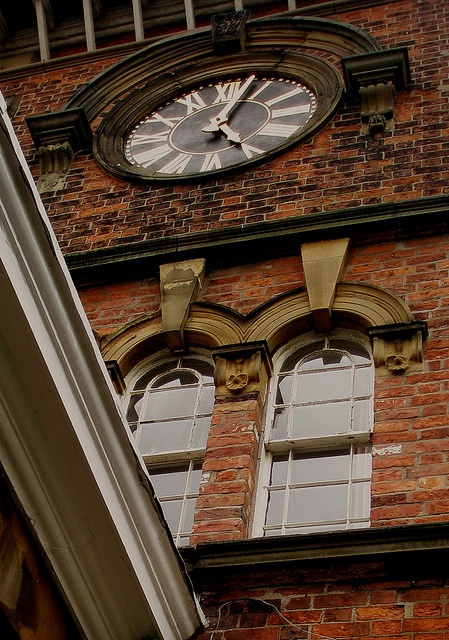Describe the objects in this image and their specific colors. I can see a clock in black, gray, and darkgray tones in this image. 